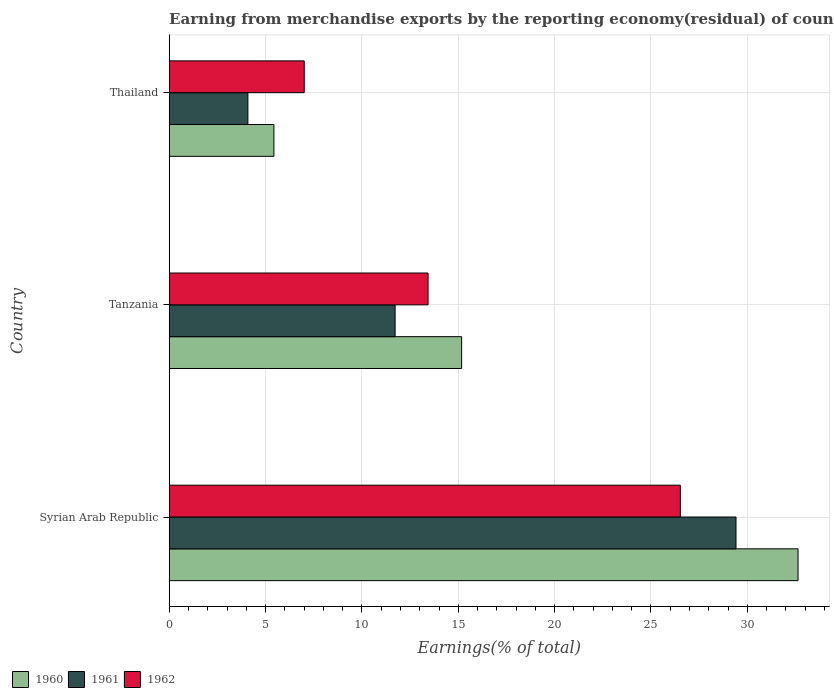Are the number of bars per tick equal to the number of legend labels?
Your answer should be compact. Yes. Are the number of bars on each tick of the Y-axis equal?
Offer a terse response. Yes. How many bars are there on the 3rd tick from the top?
Give a very brief answer. 3. How many bars are there on the 2nd tick from the bottom?
Make the answer very short. 3. What is the label of the 3rd group of bars from the top?
Offer a very short reply. Syrian Arab Republic. In how many cases, is the number of bars for a given country not equal to the number of legend labels?
Your response must be concise. 0. What is the percentage of amount earned from merchandise exports in 1960 in Syrian Arab Republic?
Your answer should be compact. 32.63. Across all countries, what is the maximum percentage of amount earned from merchandise exports in 1961?
Ensure brevity in your answer.  29.41. Across all countries, what is the minimum percentage of amount earned from merchandise exports in 1961?
Your answer should be compact. 4.08. In which country was the percentage of amount earned from merchandise exports in 1962 maximum?
Provide a short and direct response. Syrian Arab Republic. In which country was the percentage of amount earned from merchandise exports in 1962 minimum?
Your answer should be compact. Thailand. What is the total percentage of amount earned from merchandise exports in 1961 in the graph?
Provide a succinct answer. 45.22. What is the difference between the percentage of amount earned from merchandise exports in 1960 in Syrian Arab Republic and that in Thailand?
Make the answer very short. 27.2. What is the difference between the percentage of amount earned from merchandise exports in 1960 in Thailand and the percentage of amount earned from merchandise exports in 1961 in Syrian Arab Republic?
Your answer should be compact. -23.98. What is the average percentage of amount earned from merchandise exports in 1961 per country?
Provide a succinct answer. 15.07. What is the difference between the percentage of amount earned from merchandise exports in 1960 and percentage of amount earned from merchandise exports in 1962 in Thailand?
Provide a short and direct response. -1.57. What is the ratio of the percentage of amount earned from merchandise exports in 1960 in Syrian Arab Republic to that in Tanzania?
Offer a terse response. 2.15. Is the percentage of amount earned from merchandise exports in 1962 in Syrian Arab Republic less than that in Thailand?
Keep it short and to the point. No. What is the difference between the highest and the second highest percentage of amount earned from merchandise exports in 1961?
Provide a succinct answer. 17.69. What is the difference between the highest and the lowest percentage of amount earned from merchandise exports in 1960?
Offer a very short reply. 27.2. How many bars are there?
Your response must be concise. 9. Are all the bars in the graph horizontal?
Ensure brevity in your answer.  Yes. What is the difference between two consecutive major ticks on the X-axis?
Keep it short and to the point. 5. Are the values on the major ticks of X-axis written in scientific E-notation?
Keep it short and to the point. No. Does the graph contain grids?
Your response must be concise. Yes. What is the title of the graph?
Offer a very short reply. Earning from merchandise exports by the reporting economy(residual) of countries. Does "1987" appear as one of the legend labels in the graph?
Provide a succinct answer. No. What is the label or title of the X-axis?
Provide a succinct answer. Earnings(% of total). What is the label or title of the Y-axis?
Give a very brief answer. Country. What is the Earnings(% of total) of 1960 in Syrian Arab Republic?
Keep it short and to the point. 32.63. What is the Earnings(% of total) in 1961 in Syrian Arab Republic?
Keep it short and to the point. 29.41. What is the Earnings(% of total) in 1962 in Syrian Arab Republic?
Provide a short and direct response. 26.52. What is the Earnings(% of total) in 1960 in Tanzania?
Provide a short and direct response. 15.18. What is the Earnings(% of total) in 1961 in Tanzania?
Provide a short and direct response. 11.72. What is the Earnings(% of total) of 1962 in Tanzania?
Provide a succinct answer. 13.43. What is the Earnings(% of total) in 1960 in Thailand?
Your response must be concise. 5.43. What is the Earnings(% of total) in 1961 in Thailand?
Provide a short and direct response. 4.08. What is the Earnings(% of total) of 1962 in Thailand?
Your response must be concise. 7.01. Across all countries, what is the maximum Earnings(% of total) of 1960?
Your answer should be compact. 32.63. Across all countries, what is the maximum Earnings(% of total) of 1961?
Your answer should be very brief. 29.41. Across all countries, what is the maximum Earnings(% of total) in 1962?
Ensure brevity in your answer.  26.52. Across all countries, what is the minimum Earnings(% of total) of 1960?
Provide a succinct answer. 5.43. Across all countries, what is the minimum Earnings(% of total) in 1961?
Keep it short and to the point. 4.08. Across all countries, what is the minimum Earnings(% of total) of 1962?
Keep it short and to the point. 7.01. What is the total Earnings(% of total) in 1960 in the graph?
Give a very brief answer. 53.24. What is the total Earnings(% of total) of 1961 in the graph?
Make the answer very short. 45.22. What is the total Earnings(% of total) of 1962 in the graph?
Provide a succinct answer. 46.96. What is the difference between the Earnings(% of total) of 1960 in Syrian Arab Republic and that in Tanzania?
Keep it short and to the point. 17.46. What is the difference between the Earnings(% of total) of 1961 in Syrian Arab Republic and that in Tanzania?
Your answer should be compact. 17.69. What is the difference between the Earnings(% of total) in 1962 in Syrian Arab Republic and that in Tanzania?
Offer a very short reply. 13.09. What is the difference between the Earnings(% of total) in 1960 in Syrian Arab Republic and that in Thailand?
Provide a succinct answer. 27.2. What is the difference between the Earnings(% of total) in 1961 in Syrian Arab Republic and that in Thailand?
Offer a terse response. 25.33. What is the difference between the Earnings(% of total) of 1962 in Syrian Arab Republic and that in Thailand?
Offer a very short reply. 19.52. What is the difference between the Earnings(% of total) of 1960 in Tanzania and that in Thailand?
Make the answer very short. 9.74. What is the difference between the Earnings(% of total) in 1961 in Tanzania and that in Thailand?
Offer a very short reply. 7.64. What is the difference between the Earnings(% of total) in 1962 in Tanzania and that in Thailand?
Your answer should be compact. 6.43. What is the difference between the Earnings(% of total) in 1960 in Syrian Arab Republic and the Earnings(% of total) in 1961 in Tanzania?
Offer a very short reply. 20.91. What is the difference between the Earnings(% of total) of 1960 in Syrian Arab Republic and the Earnings(% of total) of 1962 in Tanzania?
Provide a succinct answer. 19.2. What is the difference between the Earnings(% of total) of 1961 in Syrian Arab Republic and the Earnings(% of total) of 1962 in Tanzania?
Provide a succinct answer. 15.98. What is the difference between the Earnings(% of total) in 1960 in Syrian Arab Republic and the Earnings(% of total) in 1961 in Thailand?
Provide a short and direct response. 28.55. What is the difference between the Earnings(% of total) in 1960 in Syrian Arab Republic and the Earnings(% of total) in 1962 in Thailand?
Your answer should be very brief. 25.62. What is the difference between the Earnings(% of total) of 1961 in Syrian Arab Republic and the Earnings(% of total) of 1962 in Thailand?
Offer a terse response. 22.4. What is the difference between the Earnings(% of total) in 1960 in Tanzania and the Earnings(% of total) in 1961 in Thailand?
Your response must be concise. 11.09. What is the difference between the Earnings(% of total) in 1960 in Tanzania and the Earnings(% of total) in 1962 in Thailand?
Give a very brief answer. 8.17. What is the difference between the Earnings(% of total) in 1961 in Tanzania and the Earnings(% of total) in 1962 in Thailand?
Your answer should be very brief. 4.72. What is the average Earnings(% of total) in 1960 per country?
Ensure brevity in your answer.  17.75. What is the average Earnings(% of total) in 1961 per country?
Keep it short and to the point. 15.07. What is the average Earnings(% of total) of 1962 per country?
Give a very brief answer. 15.65. What is the difference between the Earnings(% of total) of 1960 and Earnings(% of total) of 1961 in Syrian Arab Republic?
Your response must be concise. 3.22. What is the difference between the Earnings(% of total) of 1960 and Earnings(% of total) of 1962 in Syrian Arab Republic?
Ensure brevity in your answer.  6.11. What is the difference between the Earnings(% of total) in 1961 and Earnings(% of total) in 1962 in Syrian Arab Republic?
Provide a short and direct response. 2.89. What is the difference between the Earnings(% of total) in 1960 and Earnings(% of total) in 1961 in Tanzania?
Your response must be concise. 3.45. What is the difference between the Earnings(% of total) in 1960 and Earnings(% of total) in 1962 in Tanzania?
Provide a succinct answer. 1.74. What is the difference between the Earnings(% of total) in 1961 and Earnings(% of total) in 1962 in Tanzania?
Your response must be concise. -1.71. What is the difference between the Earnings(% of total) of 1960 and Earnings(% of total) of 1961 in Thailand?
Offer a very short reply. 1.35. What is the difference between the Earnings(% of total) in 1960 and Earnings(% of total) in 1962 in Thailand?
Keep it short and to the point. -1.57. What is the difference between the Earnings(% of total) in 1961 and Earnings(% of total) in 1962 in Thailand?
Ensure brevity in your answer.  -2.92. What is the ratio of the Earnings(% of total) of 1960 in Syrian Arab Republic to that in Tanzania?
Give a very brief answer. 2.15. What is the ratio of the Earnings(% of total) of 1961 in Syrian Arab Republic to that in Tanzania?
Provide a short and direct response. 2.51. What is the ratio of the Earnings(% of total) of 1962 in Syrian Arab Republic to that in Tanzania?
Offer a very short reply. 1.97. What is the ratio of the Earnings(% of total) of 1960 in Syrian Arab Republic to that in Thailand?
Make the answer very short. 6.01. What is the ratio of the Earnings(% of total) of 1961 in Syrian Arab Republic to that in Thailand?
Keep it short and to the point. 7.2. What is the ratio of the Earnings(% of total) of 1962 in Syrian Arab Republic to that in Thailand?
Your response must be concise. 3.79. What is the ratio of the Earnings(% of total) in 1960 in Tanzania to that in Thailand?
Your response must be concise. 2.79. What is the ratio of the Earnings(% of total) in 1961 in Tanzania to that in Thailand?
Provide a short and direct response. 2.87. What is the ratio of the Earnings(% of total) of 1962 in Tanzania to that in Thailand?
Your answer should be very brief. 1.92. What is the difference between the highest and the second highest Earnings(% of total) of 1960?
Ensure brevity in your answer.  17.46. What is the difference between the highest and the second highest Earnings(% of total) in 1961?
Make the answer very short. 17.69. What is the difference between the highest and the second highest Earnings(% of total) in 1962?
Your response must be concise. 13.09. What is the difference between the highest and the lowest Earnings(% of total) of 1960?
Provide a succinct answer. 27.2. What is the difference between the highest and the lowest Earnings(% of total) in 1961?
Your answer should be compact. 25.33. What is the difference between the highest and the lowest Earnings(% of total) in 1962?
Your answer should be very brief. 19.52. 